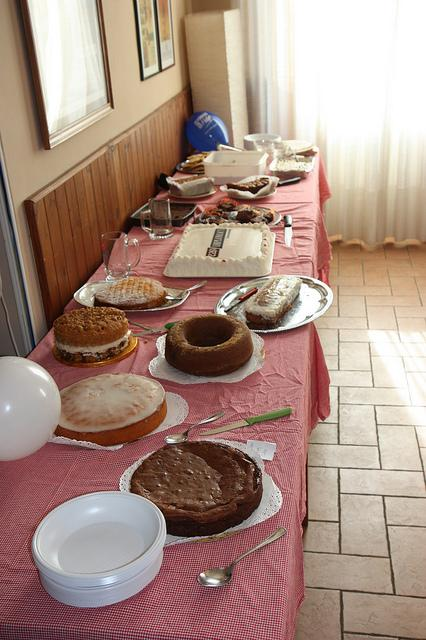How many cakes needed to cool down before adding a creamy glaze to it? Please explain your reasoning. three. I would assume all of the cakes needed to do this so one would need to identify and count the cakes and answer a is closest. 